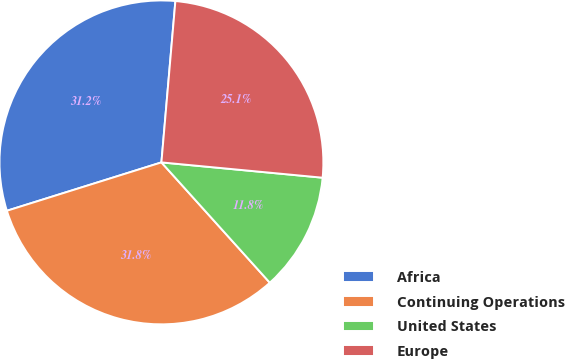<chart> <loc_0><loc_0><loc_500><loc_500><pie_chart><fcel>Africa<fcel>Continuing Operations<fcel>United States<fcel>Europe<nl><fcel>31.2%<fcel>31.84%<fcel>11.82%<fcel>25.13%<nl></chart> 